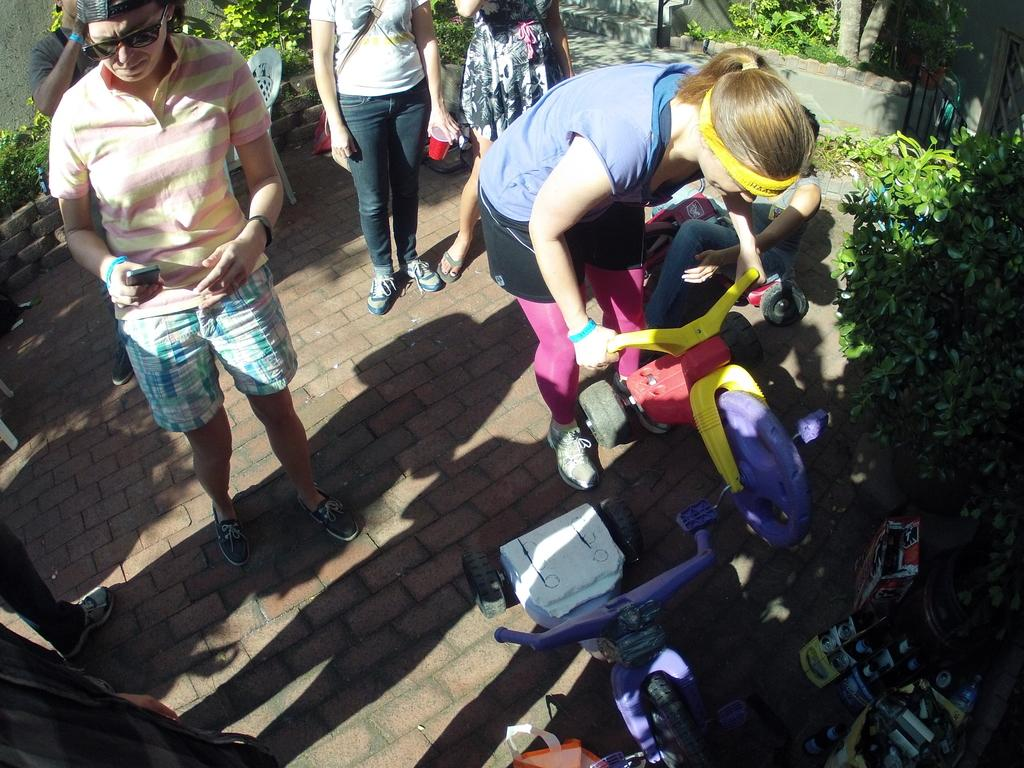Who or what can be seen in the image? There are people in the image. What else is present in the image besides people? There are plants and a chair in the image. Are there any objects related to transportation in the image? Yes, there are small bicycles in the image. What type of stem can be seen growing from the people in the image? There are no stems growing from the people in the image; they are not plants. 